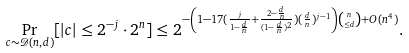<formula> <loc_0><loc_0><loc_500><loc_500>\Pr _ { c \sim \mathcal { D } ( n , d ) } [ | c | \leq 2 ^ { - j } \cdot 2 ^ { n } ] & \leq 2 ^ { - \left ( 1 - 1 7 ( \frac { j } { 1 - \frac { d } { n } } + \frac { 2 - \frac { d } { n } } { ( 1 - \frac { d } { n } ) ^ { 2 } } ) ( \frac { d } { n } ) ^ { j - 1 } \right ) \binom { n } { \leq d } + O ( n ^ { 4 } ) } .</formula> 